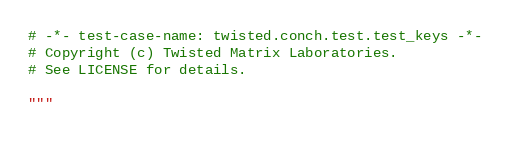<code> <loc_0><loc_0><loc_500><loc_500><_Python_># -*- test-case-name: twisted.conch.test.test_keys -*-
# Copyright (c) Twisted Matrix Laboratories.
# See LICENSE for details.

"""</code> 